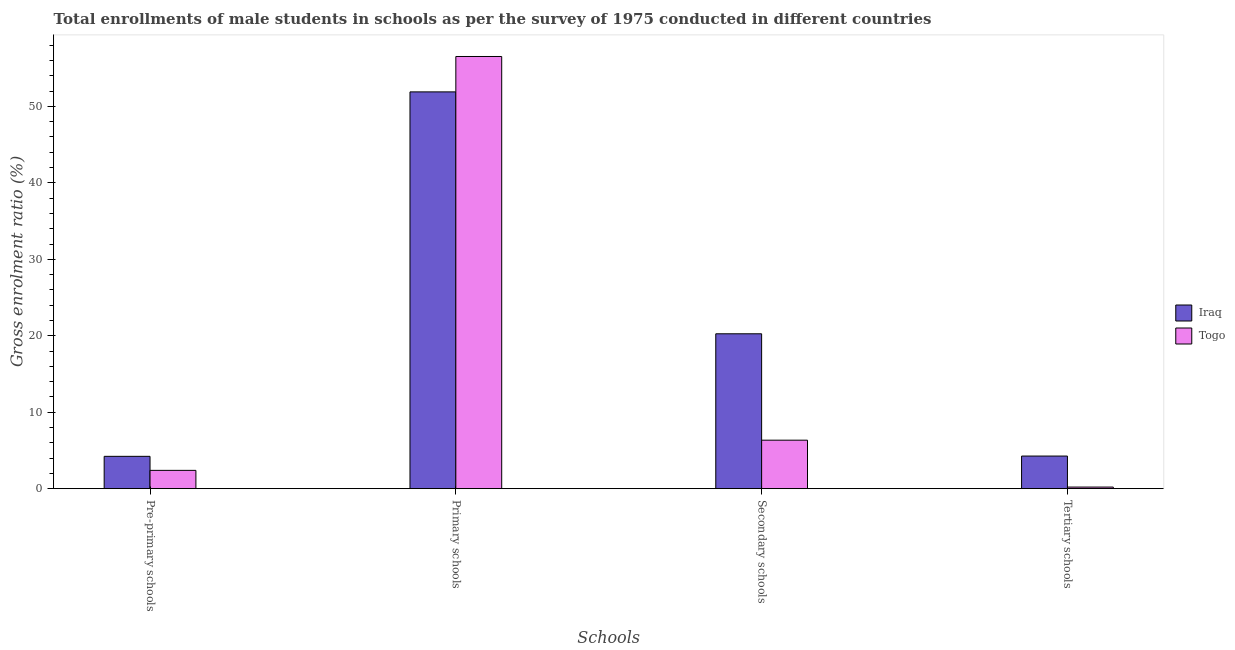Are the number of bars on each tick of the X-axis equal?
Your answer should be compact. Yes. How many bars are there on the 2nd tick from the right?
Your answer should be compact. 2. What is the label of the 2nd group of bars from the left?
Your answer should be compact. Primary schools. What is the gross enrolment ratio(male) in pre-primary schools in Togo?
Offer a very short reply. 2.39. Across all countries, what is the maximum gross enrolment ratio(male) in secondary schools?
Keep it short and to the point. 20.26. Across all countries, what is the minimum gross enrolment ratio(male) in primary schools?
Make the answer very short. 51.89. In which country was the gross enrolment ratio(male) in secondary schools maximum?
Offer a terse response. Iraq. In which country was the gross enrolment ratio(male) in primary schools minimum?
Your response must be concise. Iraq. What is the total gross enrolment ratio(male) in secondary schools in the graph?
Offer a very short reply. 26.6. What is the difference between the gross enrolment ratio(male) in secondary schools in Togo and that in Iraq?
Keep it short and to the point. -13.92. What is the difference between the gross enrolment ratio(male) in primary schools in Iraq and the gross enrolment ratio(male) in tertiary schools in Togo?
Offer a terse response. 51.69. What is the average gross enrolment ratio(male) in tertiary schools per country?
Your answer should be very brief. 2.24. What is the difference between the gross enrolment ratio(male) in secondary schools and gross enrolment ratio(male) in tertiary schools in Togo?
Offer a terse response. 6.13. In how many countries, is the gross enrolment ratio(male) in secondary schools greater than 2 %?
Your answer should be compact. 2. What is the ratio of the gross enrolment ratio(male) in pre-primary schools in Iraq to that in Togo?
Ensure brevity in your answer.  1.77. Is the gross enrolment ratio(male) in secondary schools in Togo less than that in Iraq?
Provide a short and direct response. Yes. What is the difference between the highest and the second highest gross enrolment ratio(male) in primary schools?
Offer a very short reply. 4.63. What is the difference between the highest and the lowest gross enrolment ratio(male) in primary schools?
Offer a very short reply. 4.63. Is the sum of the gross enrolment ratio(male) in primary schools in Togo and Iraq greater than the maximum gross enrolment ratio(male) in tertiary schools across all countries?
Give a very brief answer. Yes. Is it the case that in every country, the sum of the gross enrolment ratio(male) in secondary schools and gross enrolment ratio(male) in primary schools is greater than the sum of gross enrolment ratio(male) in tertiary schools and gross enrolment ratio(male) in pre-primary schools?
Provide a short and direct response. No. What does the 2nd bar from the left in Secondary schools represents?
Your answer should be compact. Togo. What does the 1st bar from the right in Tertiary schools represents?
Keep it short and to the point. Togo. How many countries are there in the graph?
Give a very brief answer. 2. Does the graph contain grids?
Offer a terse response. No. Where does the legend appear in the graph?
Your answer should be very brief. Center right. How are the legend labels stacked?
Your answer should be compact. Vertical. What is the title of the graph?
Provide a short and direct response. Total enrollments of male students in schools as per the survey of 1975 conducted in different countries. Does "Turks and Caicos Islands" appear as one of the legend labels in the graph?
Your answer should be compact. No. What is the label or title of the X-axis?
Your answer should be compact. Schools. What is the label or title of the Y-axis?
Offer a terse response. Gross enrolment ratio (%). What is the Gross enrolment ratio (%) in Iraq in Pre-primary schools?
Your answer should be very brief. 4.23. What is the Gross enrolment ratio (%) of Togo in Pre-primary schools?
Your response must be concise. 2.39. What is the Gross enrolment ratio (%) in Iraq in Primary schools?
Provide a short and direct response. 51.89. What is the Gross enrolment ratio (%) in Togo in Primary schools?
Keep it short and to the point. 56.53. What is the Gross enrolment ratio (%) of Iraq in Secondary schools?
Your answer should be compact. 20.26. What is the Gross enrolment ratio (%) of Togo in Secondary schools?
Your answer should be compact. 6.34. What is the Gross enrolment ratio (%) of Iraq in Tertiary schools?
Your answer should be very brief. 4.27. What is the Gross enrolment ratio (%) in Togo in Tertiary schools?
Your response must be concise. 0.21. Across all Schools, what is the maximum Gross enrolment ratio (%) in Iraq?
Your answer should be very brief. 51.89. Across all Schools, what is the maximum Gross enrolment ratio (%) of Togo?
Your response must be concise. 56.53. Across all Schools, what is the minimum Gross enrolment ratio (%) in Iraq?
Provide a short and direct response. 4.23. Across all Schools, what is the minimum Gross enrolment ratio (%) in Togo?
Provide a short and direct response. 0.21. What is the total Gross enrolment ratio (%) in Iraq in the graph?
Give a very brief answer. 80.65. What is the total Gross enrolment ratio (%) in Togo in the graph?
Offer a terse response. 65.47. What is the difference between the Gross enrolment ratio (%) of Iraq in Pre-primary schools and that in Primary schools?
Give a very brief answer. -47.66. What is the difference between the Gross enrolment ratio (%) in Togo in Pre-primary schools and that in Primary schools?
Offer a terse response. -54.13. What is the difference between the Gross enrolment ratio (%) of Iraq in Pre-primary schools and that in Secondary schools?
Ensure brevity in your answer.  -16.03. What is the difference between the Gross enrolment ratio (%) in Togo in Pre-primary schools and that in Secondary schools?
Make the answer very short. -3.95. What is the difference between the Gross enrolment ratio (%) in Iraq in Pre-primary schools and that in Tertiary schools?
Provide a succinct answer. -0.04. What is the difference between the Gross enrolment ratio (%) in Togo in Pre-primary schools and that in Tertiary schools?
Ensure brevity in your answer.  2.18. What is the difference between the Gross enrolment ratio (%) in Iraq in Primary schools and that in Secondary schools?
Provide a short and direct response. 31.64. What is the difference between the Gross enrolment ratio (%) of Togo in Primary schools and that in Secondary schools?
Provide a short and direct response. 50.18. What is the difference between the Gross enrolment ratio (%) in Iraq in Primary schools and that in Tertiary schools?
Offer a very short reply. 47.63. What is the difference between the Gross enrolment ratio (%) in Togo in Primary schools and that in Tertiary schools?
Provide a short and direct response. 56.32. What is the difference between the Gross enrolment ratio (%) in Iraq in Secondary schools and that in Tertiary schools?
Your response must be concise. 15.99. What is the difference between the Gross enrolment ratio (%) in Togo in Secondary schools and that in Tertiary schools?
Your response must be concise. 6.13. What is the difference between the Gross enrolment ratio (%) in Iraq in Pre-primary schools and the Gross enrolment ratio (%) in Togo in Primary schools?
Your answer should be compact. -52.29. What is the difference between the Gross enrolment ratio (%) in Iraq in Pre-primary schools and the Gross enrolment ratio (%) in Togo in Secondary schools?
Your answer should be compact. -2.11. What is the difference between the Gross enrolment ratio (%) of Iraq in Pre-primary schools and the Gross enrolment ratio (%) of Togo in Tertiary schools?
Give a very brief answer. 4.02. What is the difference between the Gross enrolment ratio (%) in Iraq in Primary schools and the Gross enrolment ratio (%) in Togo in Secondary schools?
Provide a succinct answer. 45.55. What is the difference between the Gross enrolment ratio (%) in Iraq in Primary schools and the Gross enrolment ratio (%) in Togo in Tertiary schools?
Provide a short and direct response. 51.69. What is the difference between the Gross enrolment ratio (%) of Iraq in Secondary schools and the Gross enrolment ratio (%) of Togo in Tertiary schools?
Provide a short and direct response. 20.05. What is the average Gross enrolment ratio (%) in Iraq per Schools?
Provide a short and direct response. 20.16. What is the average Gross enrolment ratio (%) of Togo per Schools?
Your response must be concise. 16.37. What is the difference between the Gross enrolment ratio (%) of Iraq and Gross enrolment ratio (%) of Togo in Pre-primary schools?
Give a very brief answer. 1.84. What is the difference between the Gross enrolment ratio (%) in Iraq and Gross enrolment ratio (%) in Togo in Primary schools?
Your response must be concise. -4.63. What is the difference between the Gross enrolment ratio (%) of Iraq and Gross enrolment ratio (%) of Togo in Secondary schools?
Ensure brevity in your answer.  13.92. What is the difference between the Gross enrolment ratio (%) in Iraq and Gross enrolment ratio (%) in Togo in Tertiary schools?
Ensure brevity in your answer.  4.06. What is the ratio of the Gross enrolment ratio (%) in Iraq in Pre-primary schools to that in Primary schools?
Offer a very short reply. 0.08. What is the ratio of the Gross enrolment ratio (%) in Togo in Pre-primary schools to that in Primary schools?
Make the answer very short. 0.04. What is the ratio of the Gross enrolment ratio (%) in Iraq in Pre-primary schools to that in Secondary schools?
Your answer should be compact. 0.21. What is the ratio of the Gross enrolment ratio (%) in Togo in Pre-primary schools to that in Secondary schools?
Your answer should be compact. 0.38. What is the ratio of the Gross enrolment ratio (%) of Togo in Pre-primary schools to that in Tertiary schools?
Keep it short and to the point. 11.41. What is the ratio of the Gross enrolment ratio (%) in Iraq in Primary schools to that in Secondary schools?
Your response must be concise. 2.56. What is the ratio of the Gross enrolment ratio (%) in Togo in Primary schools to that in Secondary schools?
Provide a succinct answer. 8.91. What is the ratio of the Gross enrolment ratio (%) in Iraq in Primary schools to that in Tertiary schools?
Your answer should be very brief. 12.16. What is the ratio of the Gross enrolment ratio (%) in Togo in Primary schools to that in Tertiary schools?
Your answer should be very brief. 269.36. What is the ratio of the Gross enrolment ratio (%) in Iraq in Secondary schools to that in Tertiary schools?
Your answer should be very brief. 4.75. What is the ratio of the Gross enrolment ratio (%) in Togo in Secondary schools to that in Tertiary schools?
Provide a short and direct response. 30.22. What is the difference between the highest and the second highest Gross enrolment ratio (%) in Iraq?
Your answer should be very brief. 31.64. What is the difference between the highest and the second highest Gross enrolment ratio (%) of Togo?
Keep it short and to the point. 50.18. What is the difference between the highest and the lowest Gross enrolment ratio (%) of Iraq?
Ensure brevity in your answer.  47.66. What is the difference between the highest and the lowest Gross enrolment ratio (%) of Togo?
Your response must be concise. 56.32. 